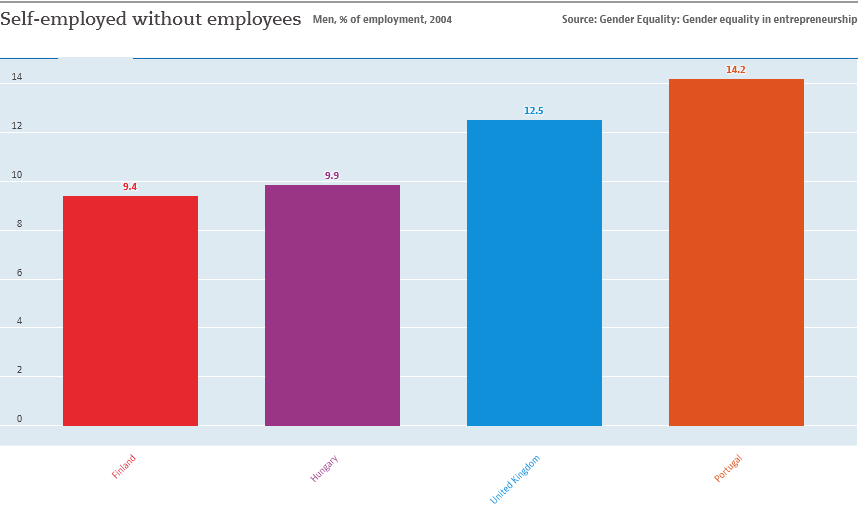Specify some key components in this picture. The average of all the bars in the graph is 11.5. In Finland, the percentage of self-employed individuals without employees is 0.094. 